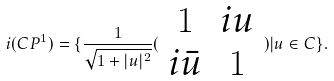Convert formula to latex. <formula><loc_0><loc_0><loc_500><loc_500>i ( C P ^ { 1 } ) = \{ \frac { 1 } { \sqrt { 1 + | u | ^ { 2 } } } ( \begin{array} { c c } 1 & i u \\ i \bar { u } & 1 \end{array} ) | u \in C \} .</formula> 